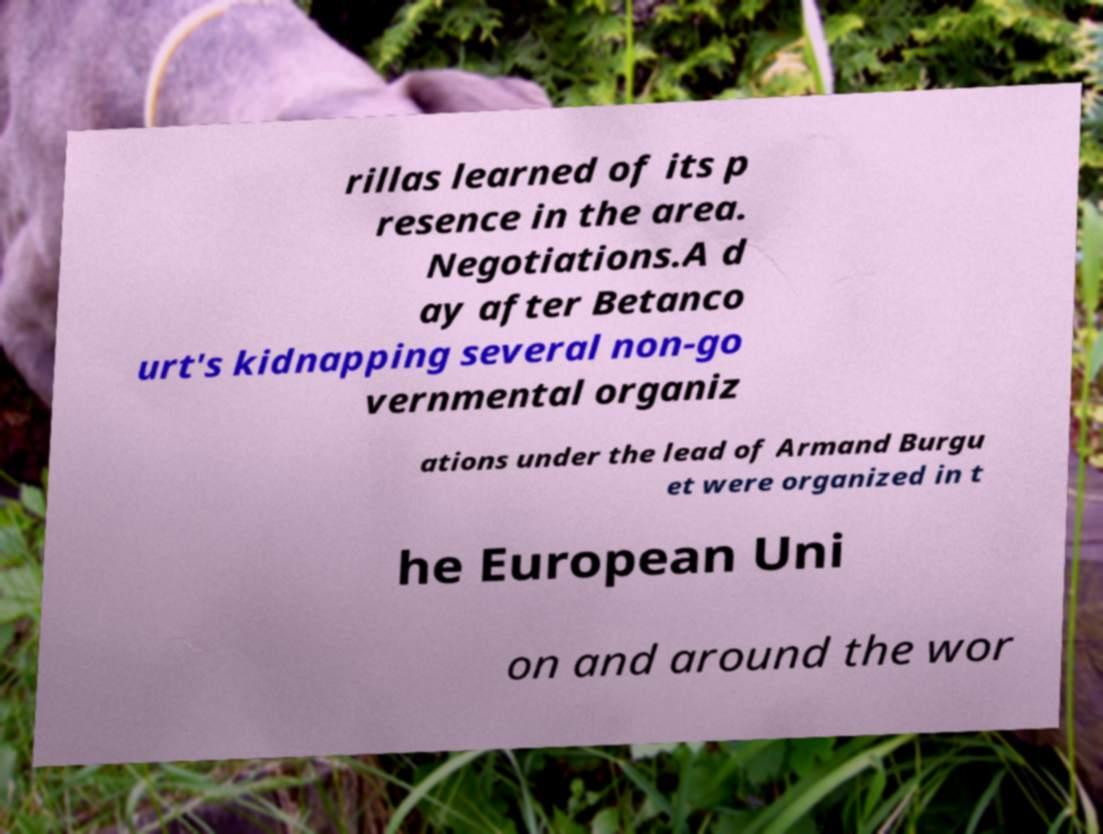Can you accurately transcribe the text from the provided image for me? rillas learned of its p resence in the area. Negotiations.A d ay after Betanco urt's kidnapping several non-go vernmental organiz ations under the lead of Armand Burgu et were organized in t he European Uni on and around the wor 